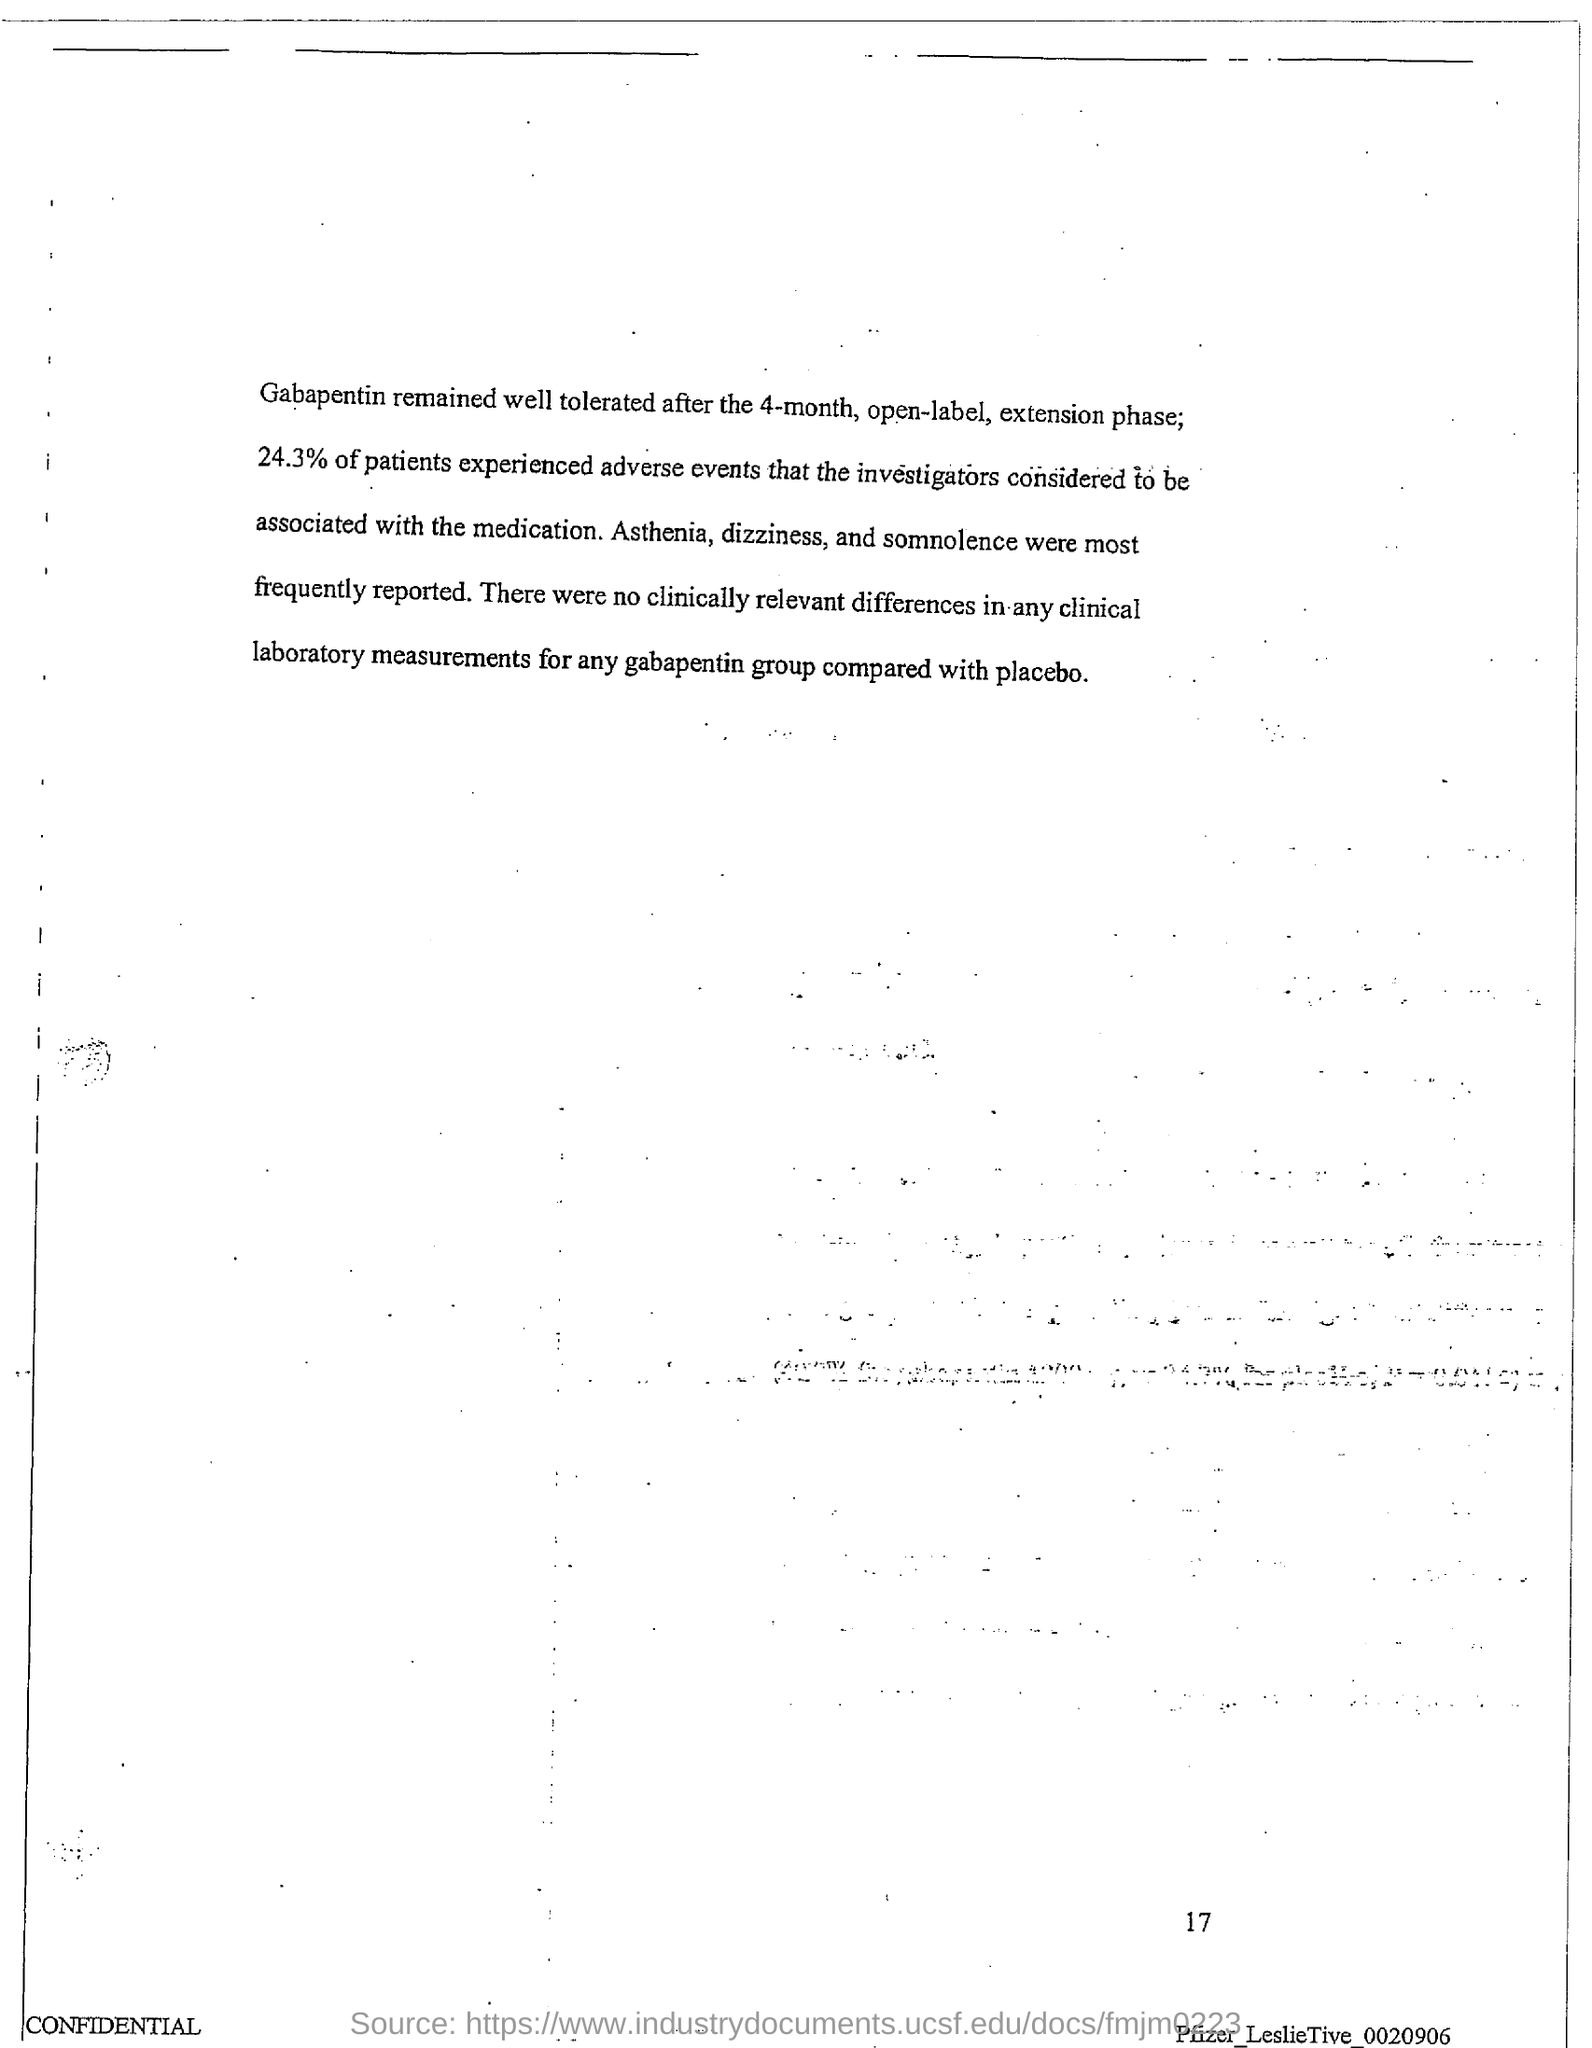What % of patients experienced adverse events?
Offer a terse response. 24.3%. 